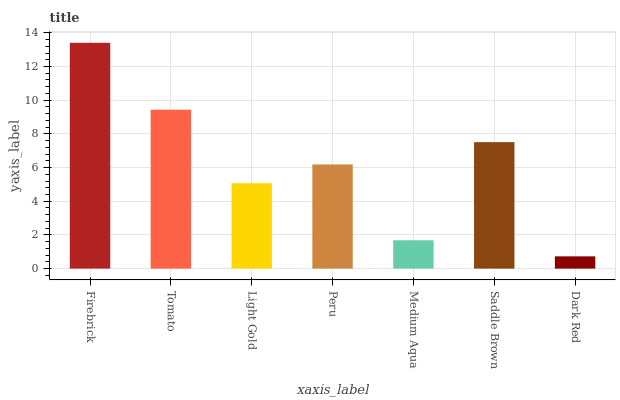Is Dark Red the minimum?
Answer yes or no. Yes. Is Firebrick the maximum?
Answer yes or no. Yes. Is Tomato the minimum?
Answer yes or no. No. Is Tomato the maximum?
Answer yes or no. No. Is Firebrick greater than Tomato?
Answer yes or no. Yes. Is Tomato less than Firebrick?
Answer yes or no. Yes. Is Tomato greater than Firebrick?
Answer yes or no. No. Is Firebrick less than Tomato?
Answer yes or no. No. Is Peru the high median?
Answer yes or no. Yes. Is Peru the low median?
Answer yes or no. Yes. Is Light Gold the high median?
Answer yes or no. No. Is Medium Aqua the low median?
Answer yes or no. No. 